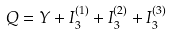<formula> <loc_0><loc_0><loc_500><loc_500>Q = Y + I _ { 3 } ^ { ( 1 ) } + I _ { 3 } ^ { ( 2 ) } + I _ { 3 } ^ { ( 3 ) }</formula> 